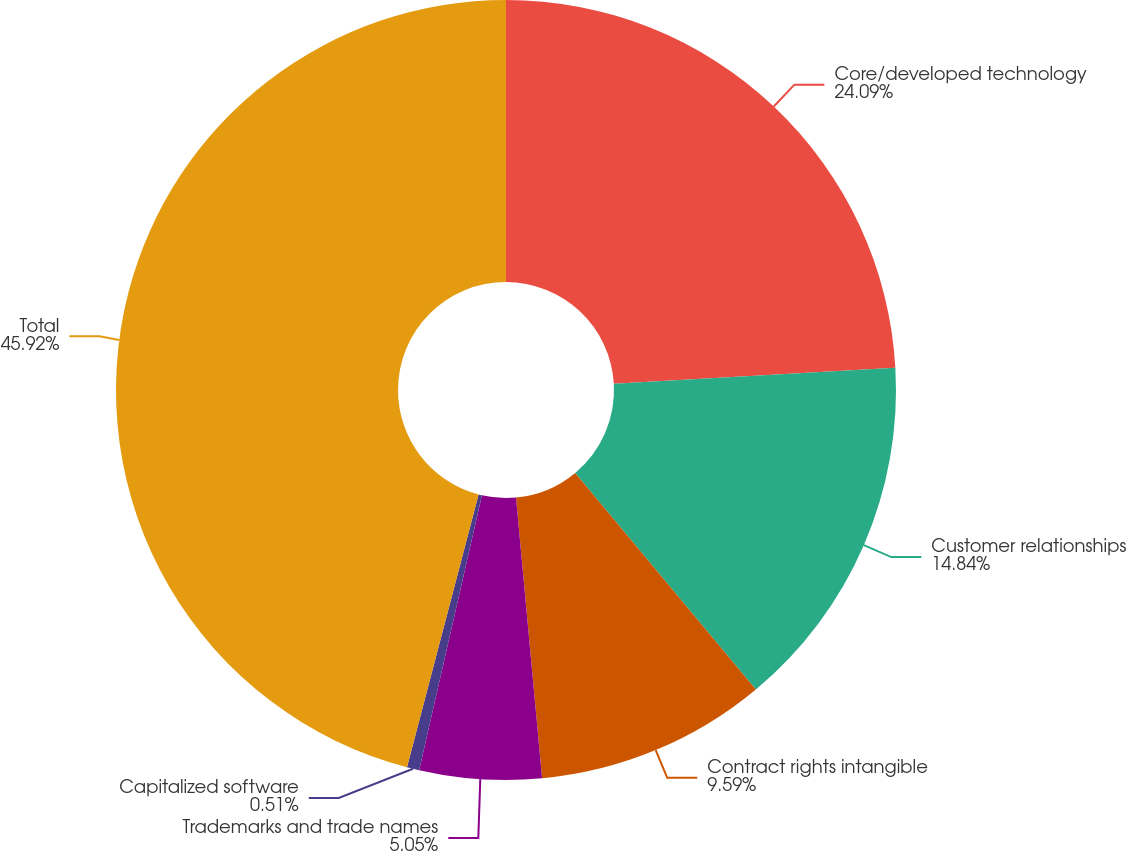Convert chart to OTSL. <chart><loc_0><loc_0><loc_500><loc_500><pie_chart><fcel>Core/developed technology<fcel>Customer relationships<fcel>Contract rights intangible<fcel>Trademarks and trade names<fcel>Capitalized software<fcel>Total<nl><fcel>24.09%<fcel>14.84%<fcel>9.59%<fcel>5.05%<fcel>0.51%<fcel>45.91%<nl></chart> 